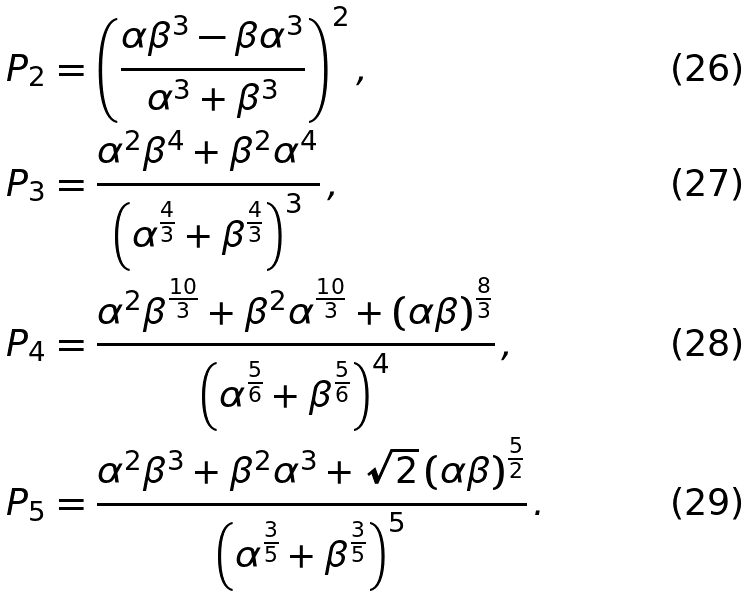Convert formula to latex. <formula><loc_0><loc_0><loc_500><loc_500>P _ { 2 } & = \left ( \frac { \alpha \beta ^ { 3 } - \beta \alpha ^ { 3 } } { \alpha ^ { 3 } + \beta ^ { 3 } } \right ) ^ { 2 } , \\ P _ { 3 } & = \frac { \alpha ^ { 2 } \beta ^ { 4 } + \beta ^ { 2 } \alpha ^ { 4 } } { \left ( \alpha ^ { \frac { 4 } { 3 } } + \beta ^ { \frac { 4 } { 3 } } \right ) ^ { 3 } } \, , \\ P _ { 4 } & = \frac { \alpha ^ { 2 } \beta ^ { \frac { 1 0 } { 3 } } + \beta ^ { 2 } \alpha ^ { \frac { 1 0 } { 3 } } + \left ( \alpha \beta \right ) ^ { \frac { 8 } { 3 } } } { \left ( \alpha ^ { \frac { 5 } { 6 } } + \beta ^ { \frac { 5 } { 6 } } \right ) ^ { 4 } } \, , \\ P _ { 5 } & = \frac { \alpha ^ { 2 } \beta ^ { 3 } + \beta ^ { 2 } \alpha ^ { 3 } + \sqrt { 2 } \left ( \alpha \beta \right ) ^ { \frac { 5 } { 2 } } } { \left ( \alpha ^ { \frac { 3 } { 5 } } + \beta ^ { \frac { 3 } { 5 } } \right ) ^ { 5 } } \, .</formula> 